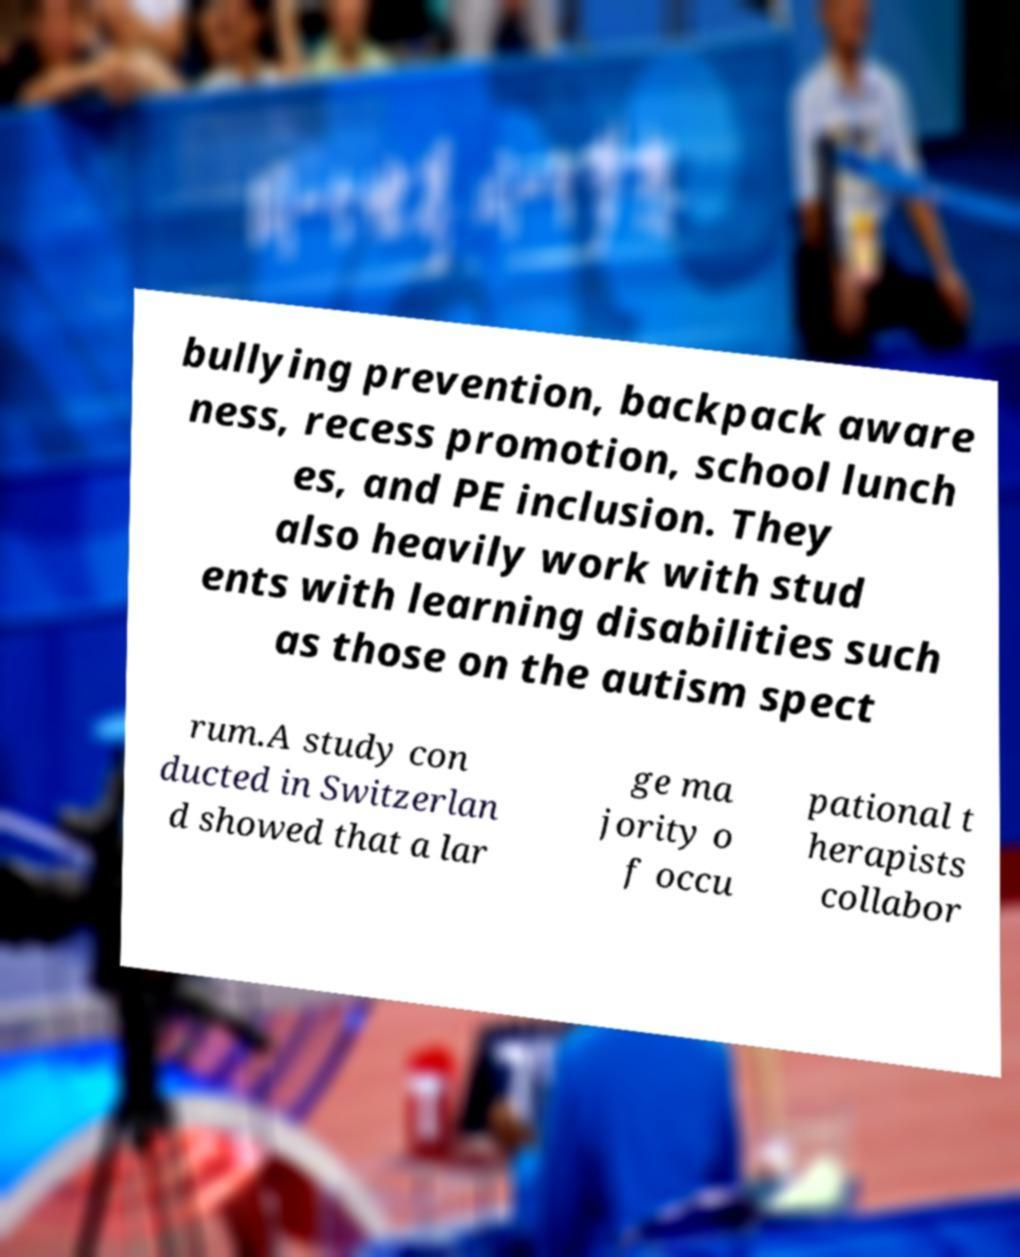Could you extract and type out the text from this image? bullying prevention, backpack aware ness, recess promotion, school lunch es, and PE inclusion. They also heavily work with stud ents with learning disabilities such as those on the autism spect rum.A study con ducted in Switzerlan d showed that a lar ge ma jority o f occu pational t herapists collabor 